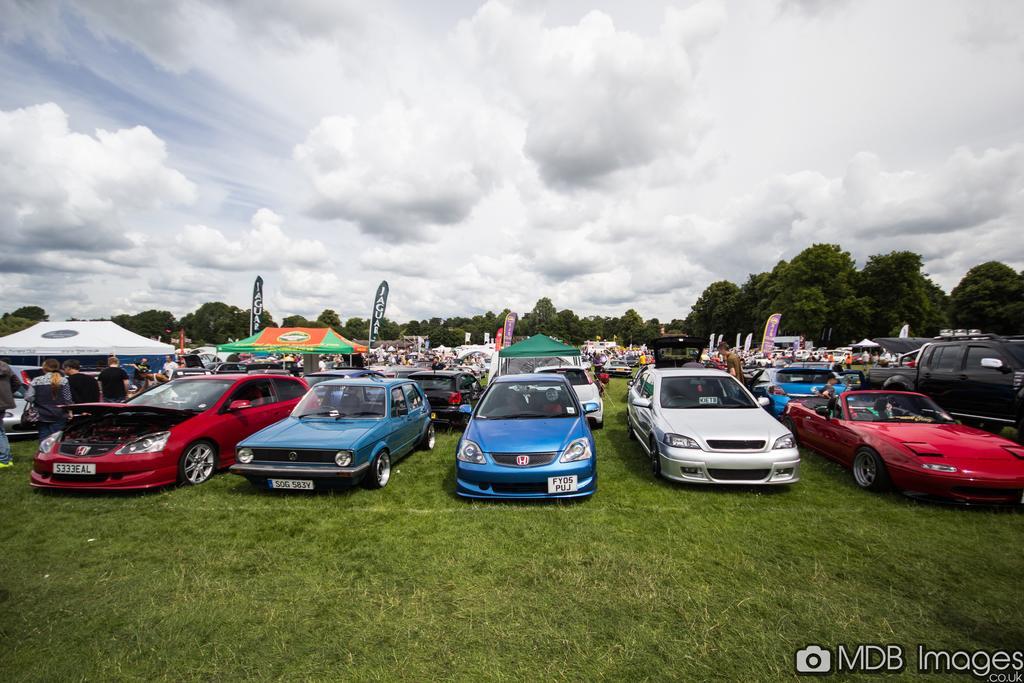How would you summarize this image in a sentence or two? At the bottom of the image there is grass on the ground. At the bottom right corner of the image there is a name. In the middle of the grass there are few cars. Behind the cars there are few people and also there are tents. In the background there are trees. And to the top of the image there is a sky with clouds. 